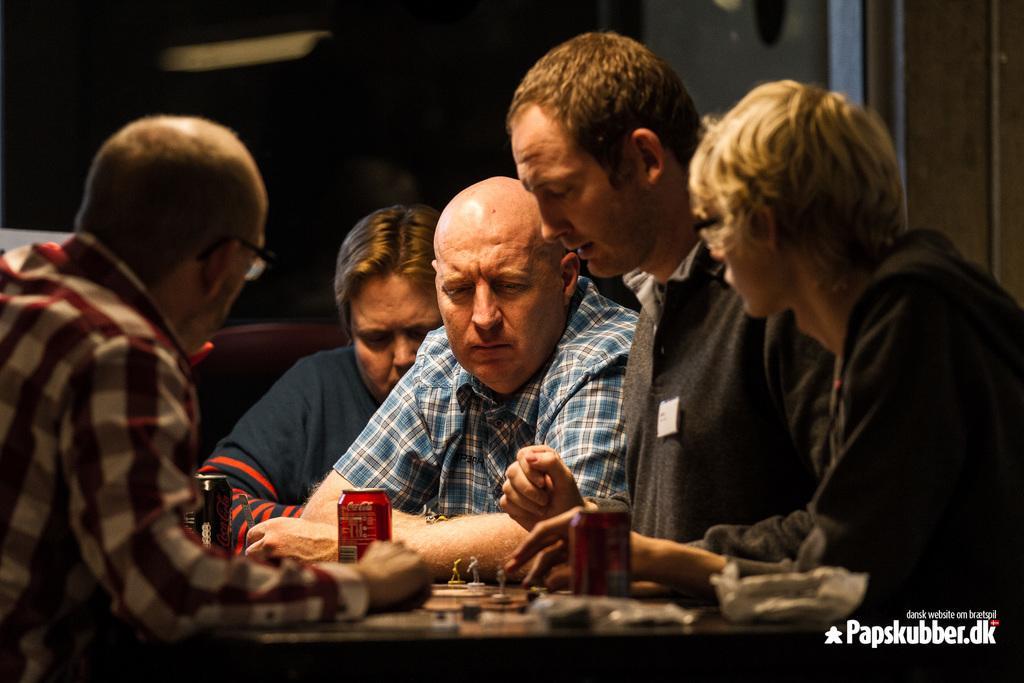Describe this image in one or two sentences. In the given image i can see a people and few objects on the table. 